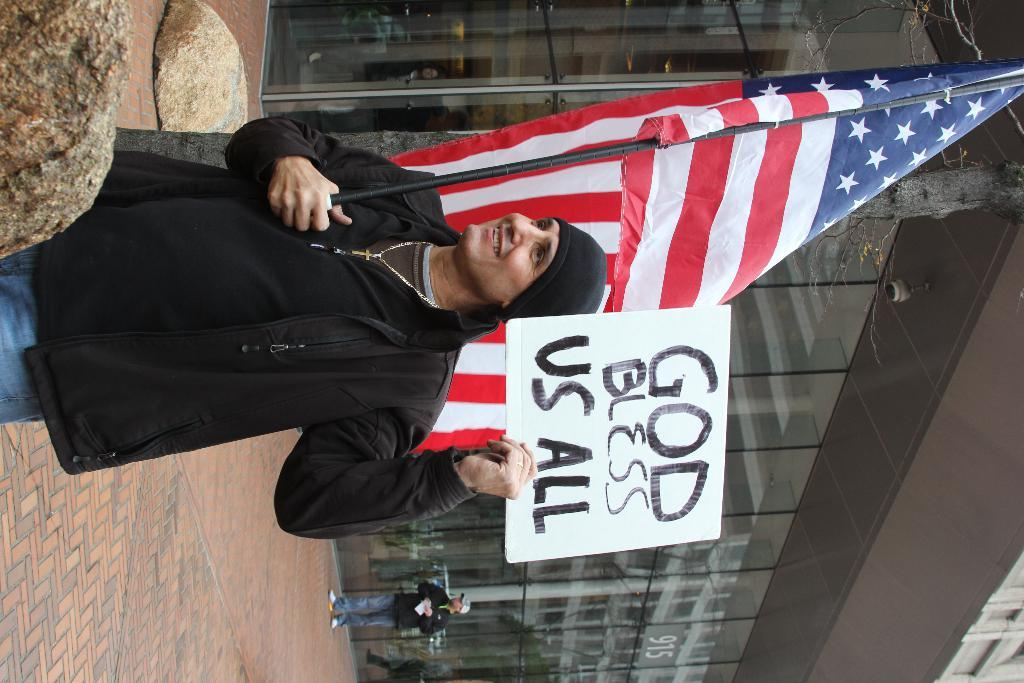What is the person in the image holding? The person is holding a flag and a poster. What might the person be trying to communicate with the flag and poster? It is not clear from the image what message the person is trying to convey, but they are likely expressing a message or idea. What can be seen in the background of the image? There are stones, people, at least one building, and the ground visible in the background of the image. What type of circle is visible on the person's glove in the image? There is no glove or circle present in the image. How does the pollution affect the people in the image? There is no mention of pollution in the image, so it cannot be determined how it might affect the people. 